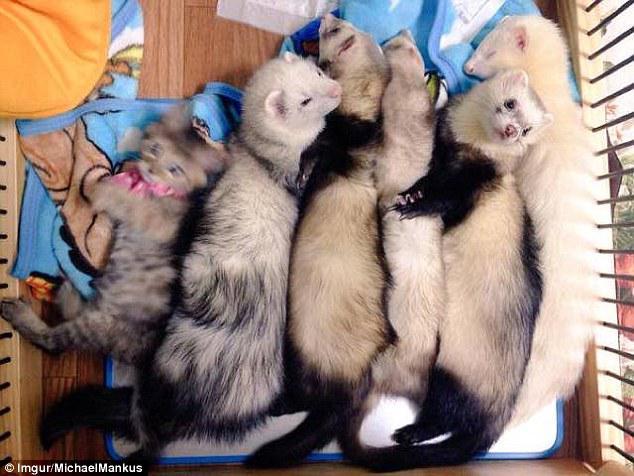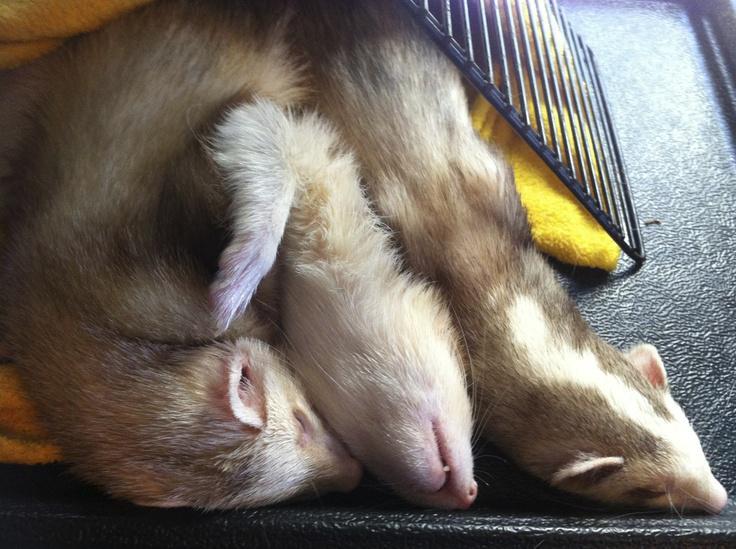The first image is the image on the left, the second image is the image on the right. Examine the images to the left and right. Is the description "All images show ferrets with their faces aligned together, and at least one image contains exactly three ferrets." accurate? Answer yes or no. Yes. 